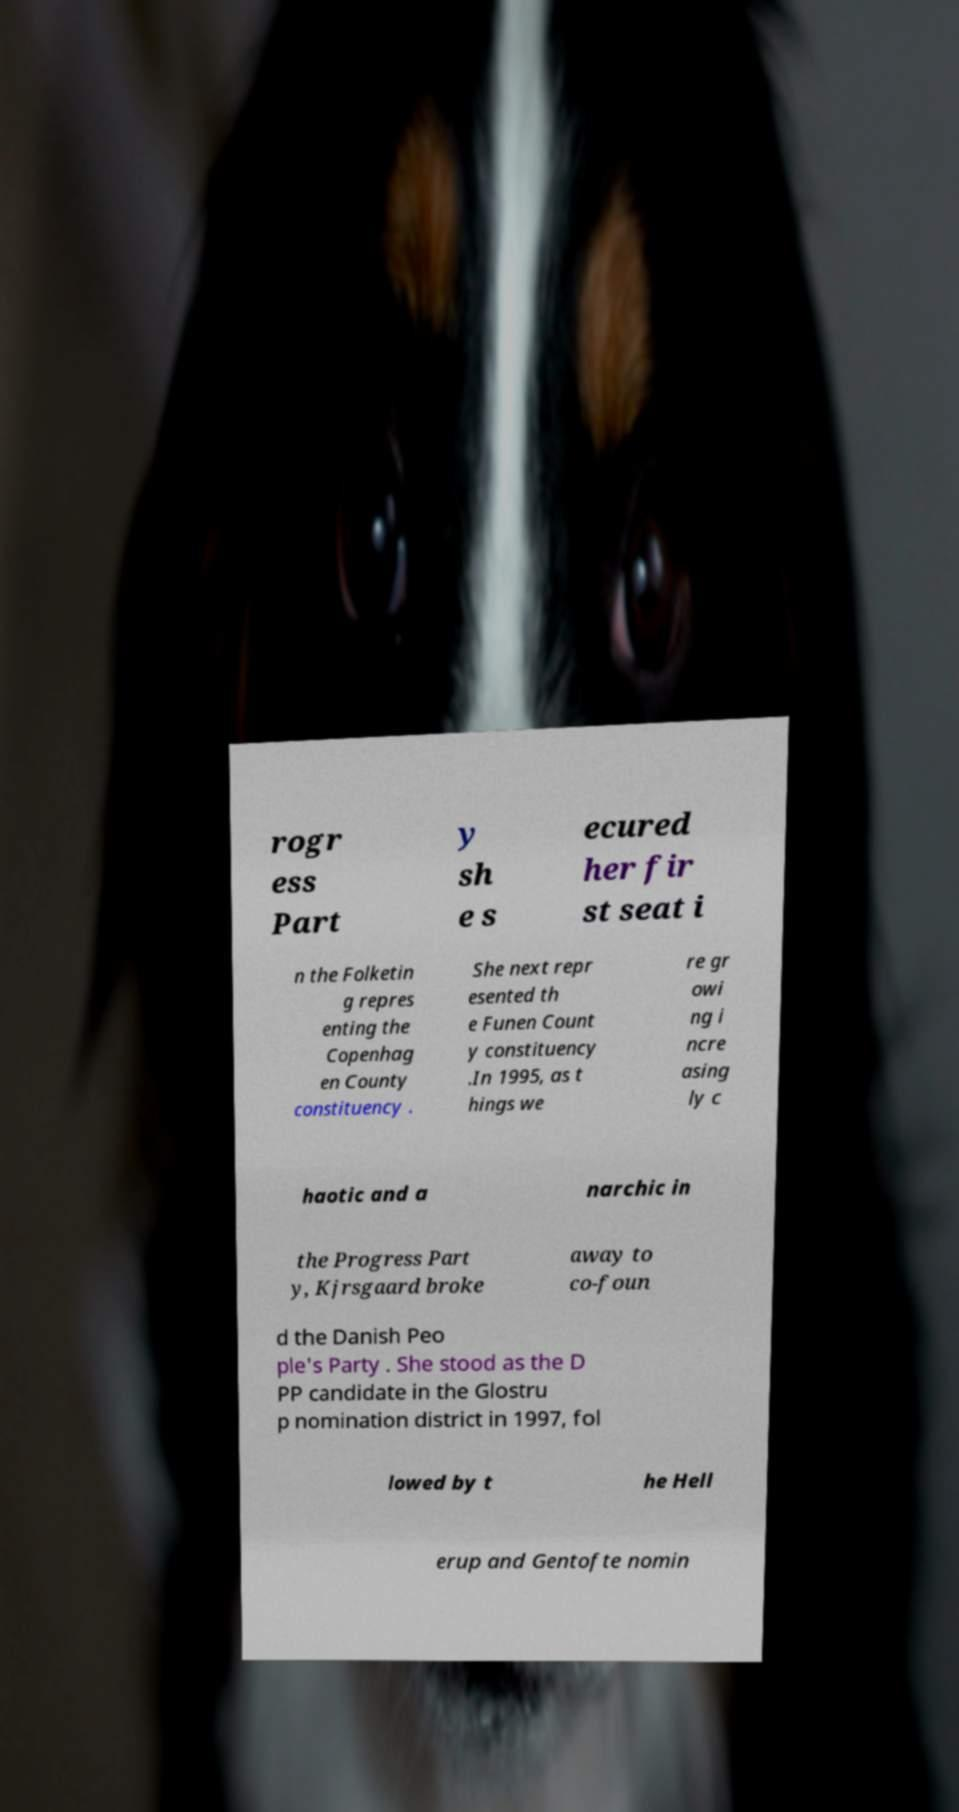Can you accurately transcribe the text from the provided image for me? rogr ess Part y sh e s ecured her fir st seat i n the Folketin g repres enting the Copenhag en County constituency . She next repr esented th e Funen Count y constituency .In 1995, as t hings we re gr owi ng i ncre asing ly c haotic and a narchic in the Progress Part y, Kjrsgaard broke away to co-foun d the Danish Peo ple's Party . She stood as the D PP candidate in the Glostru p nomination district in 1997, fol lowed by t he Hell erup and Gentofte nomin 